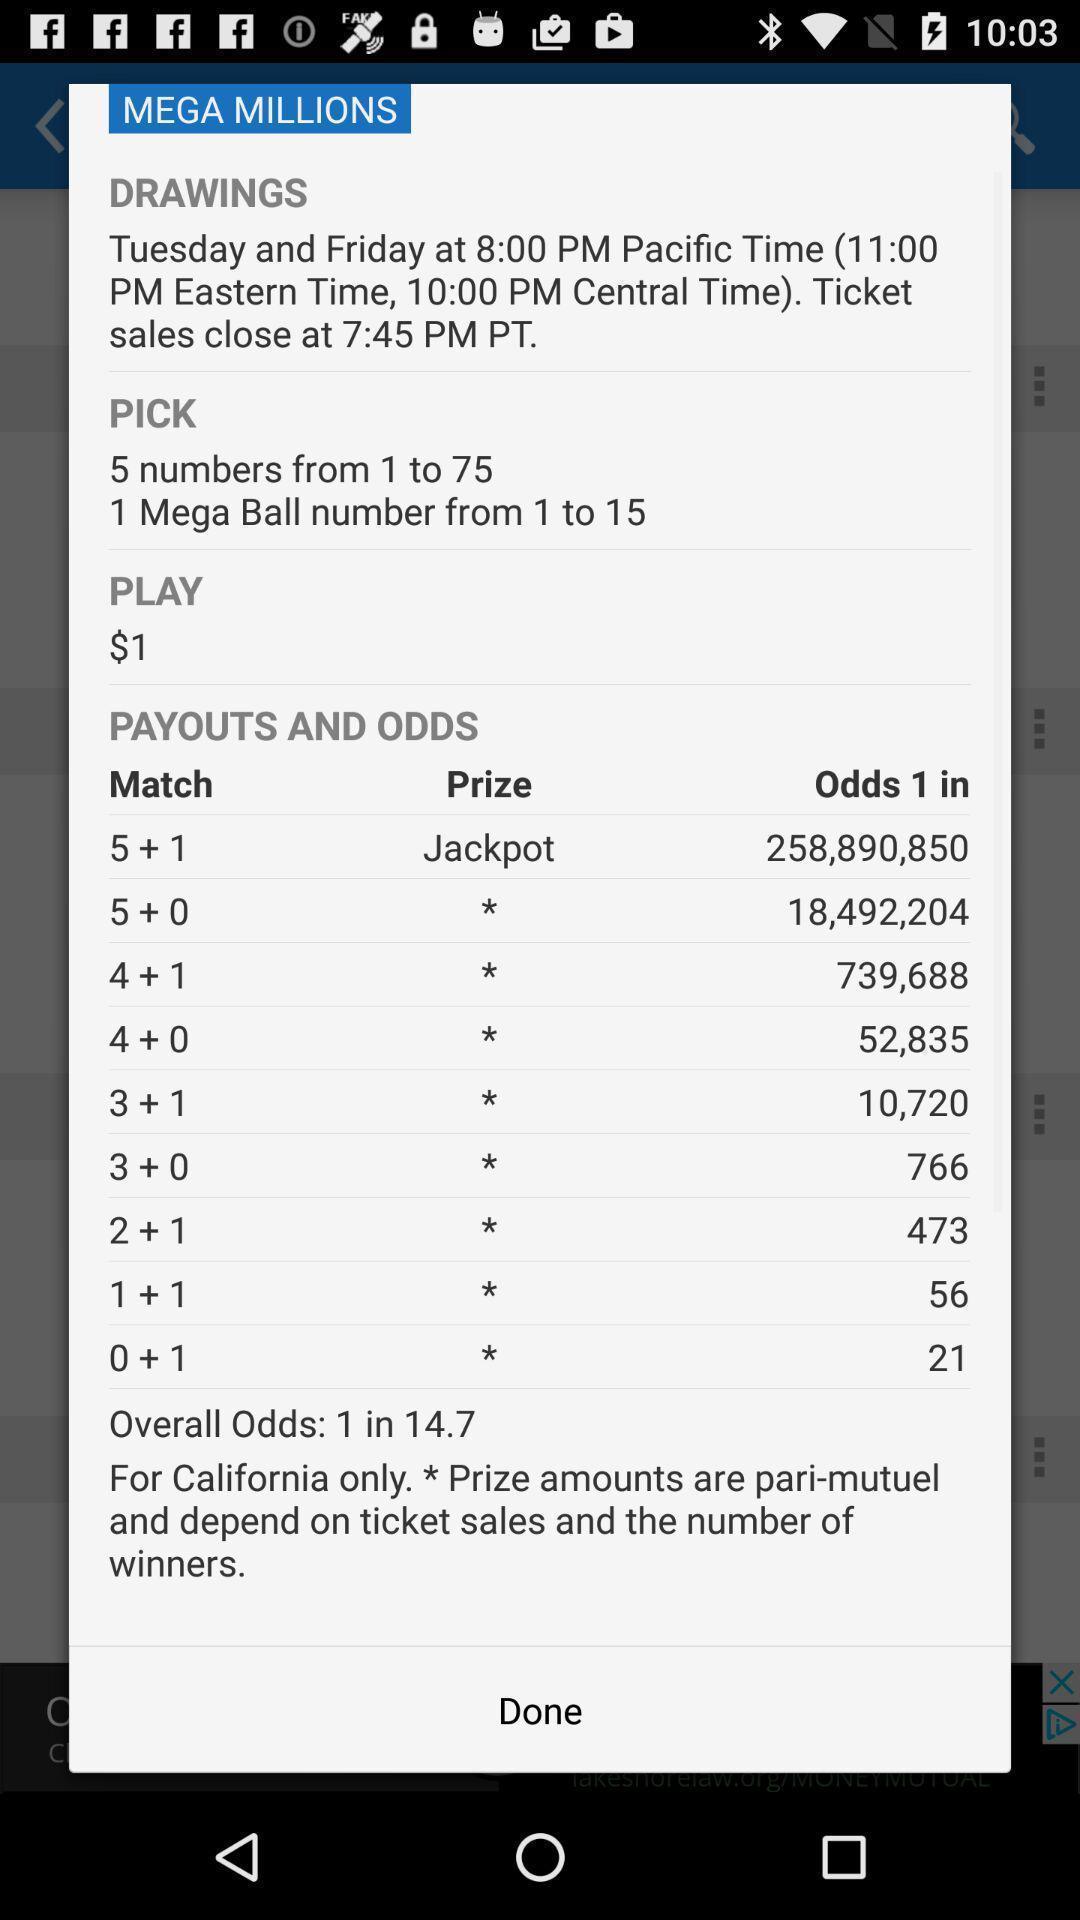Describe this image in words. Pop-up page displaying with information about game and prize amount. 